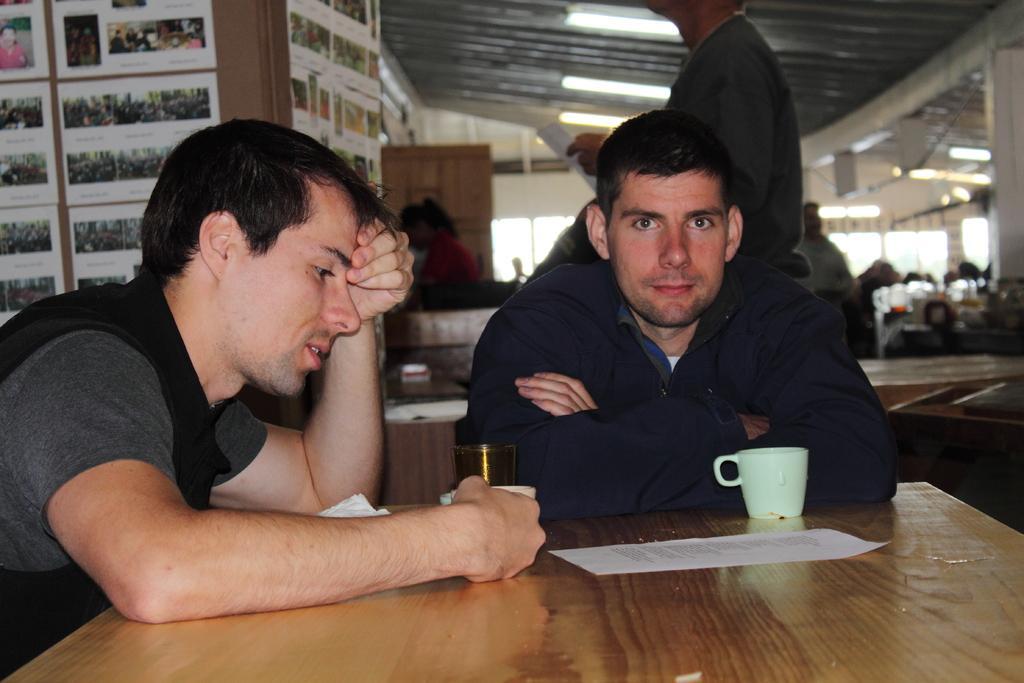In one or two sentences, can you explain what this image depicts? This is an inside view. Here I can see two men sitting on the chairs in front of the table. The man who is on the left side is holding a cup in the hand. The other man is looking at the picture. In front of him there is another cup placed on the table and also there is a paper. At the back of this man there is a person standing and holding a paper in the hand. In the background, I can see some more people. On the left side there is a board on which some papers are attached. At the top there are few lights. 